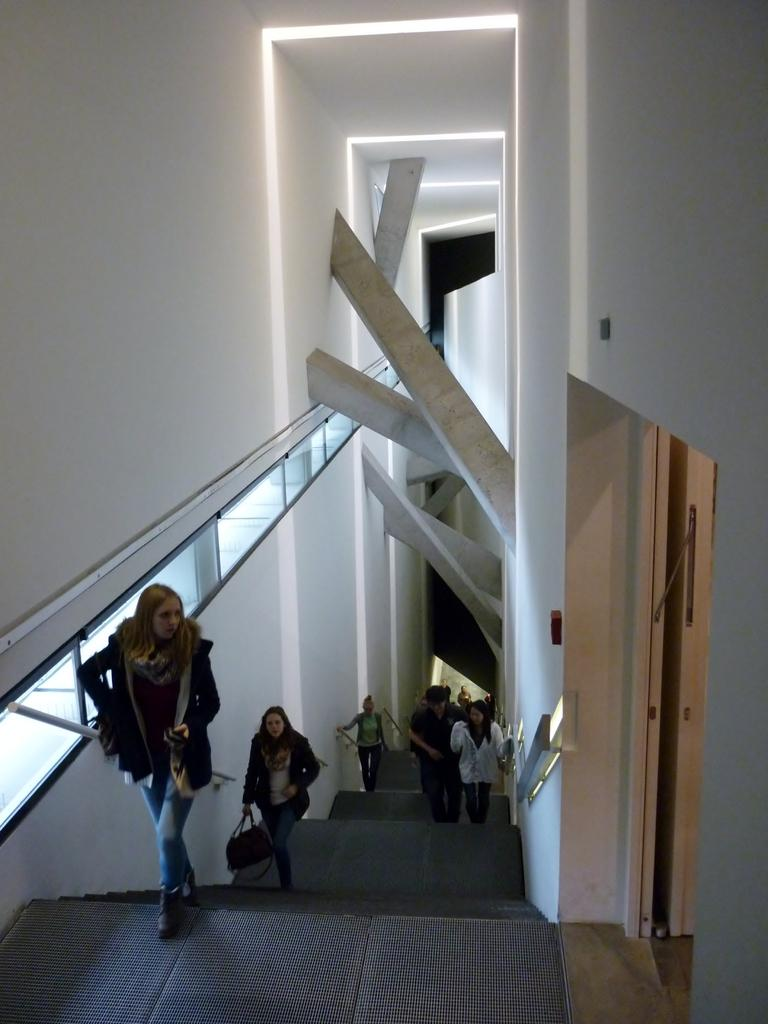What is the main subject in the middle of the image? There is a staircase in the middle of the image. What are the people in the image doing? People are walking on the staircase. Where is the entrance located in the image? There is an entrance on the right side of the image. What type of location is depicted in the image? The image is an inside part of a building. What type of toy can be seen hanging from the hook on the staircase in the image? There is no toy or hook present in the image; it only shows a staircase and people walking on it. 